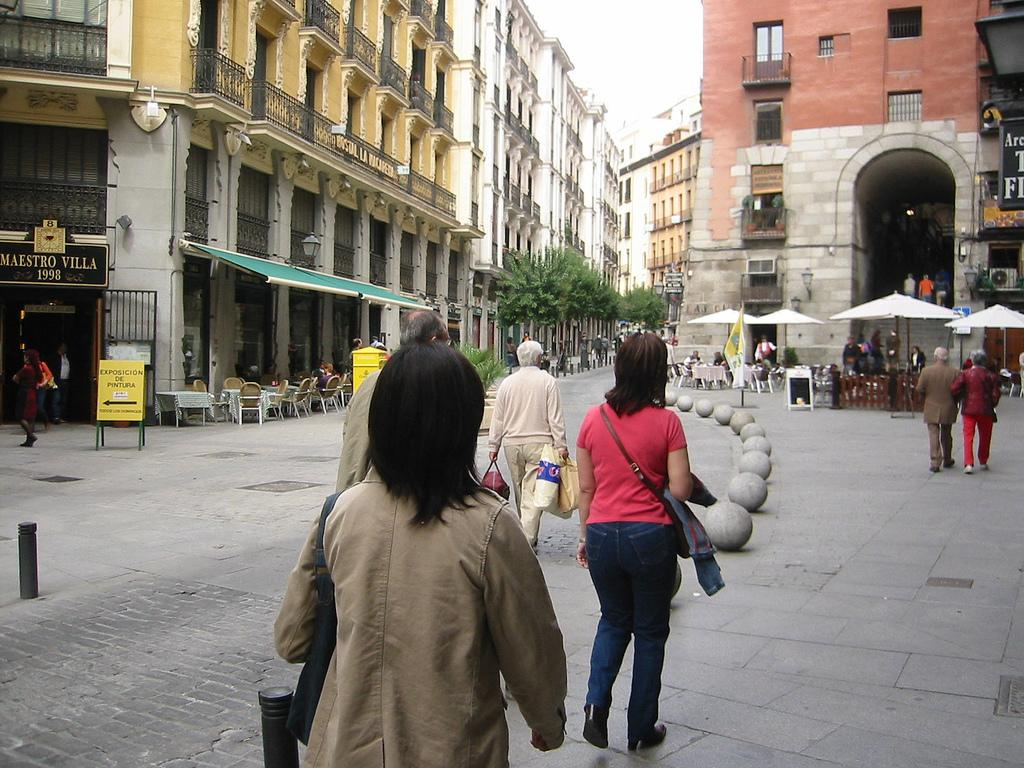Who is the main subject in the image? There is a woman in the image. What is the woman doing in the image? The woman is walking on a footpath. What is the woman wearing in the image? The woman is wearing a coat. What can be seen on the right side of the image? There are umbrellas on the right side of the image. What type of structures are visible in the image? There are buildings in the image. Reasoning: Let's think step by step by step in order to produce the conversation. We start by identifying the main subject in the image, which is the woman. Then, we describe her actions and what she is wearing. Next, we mention the umbrellas on the right side of the image, as well as the buildings in the image. Each question is designed to elicit a specific detail about the image that is known from the provided facts. Absurd Question/Answer: What rhythm is the woman walking to in the image? There is no indication of a specific rhythm in the woman's walk in the image. How many clocks are visible in the image? There are no clocks visible in the image. 